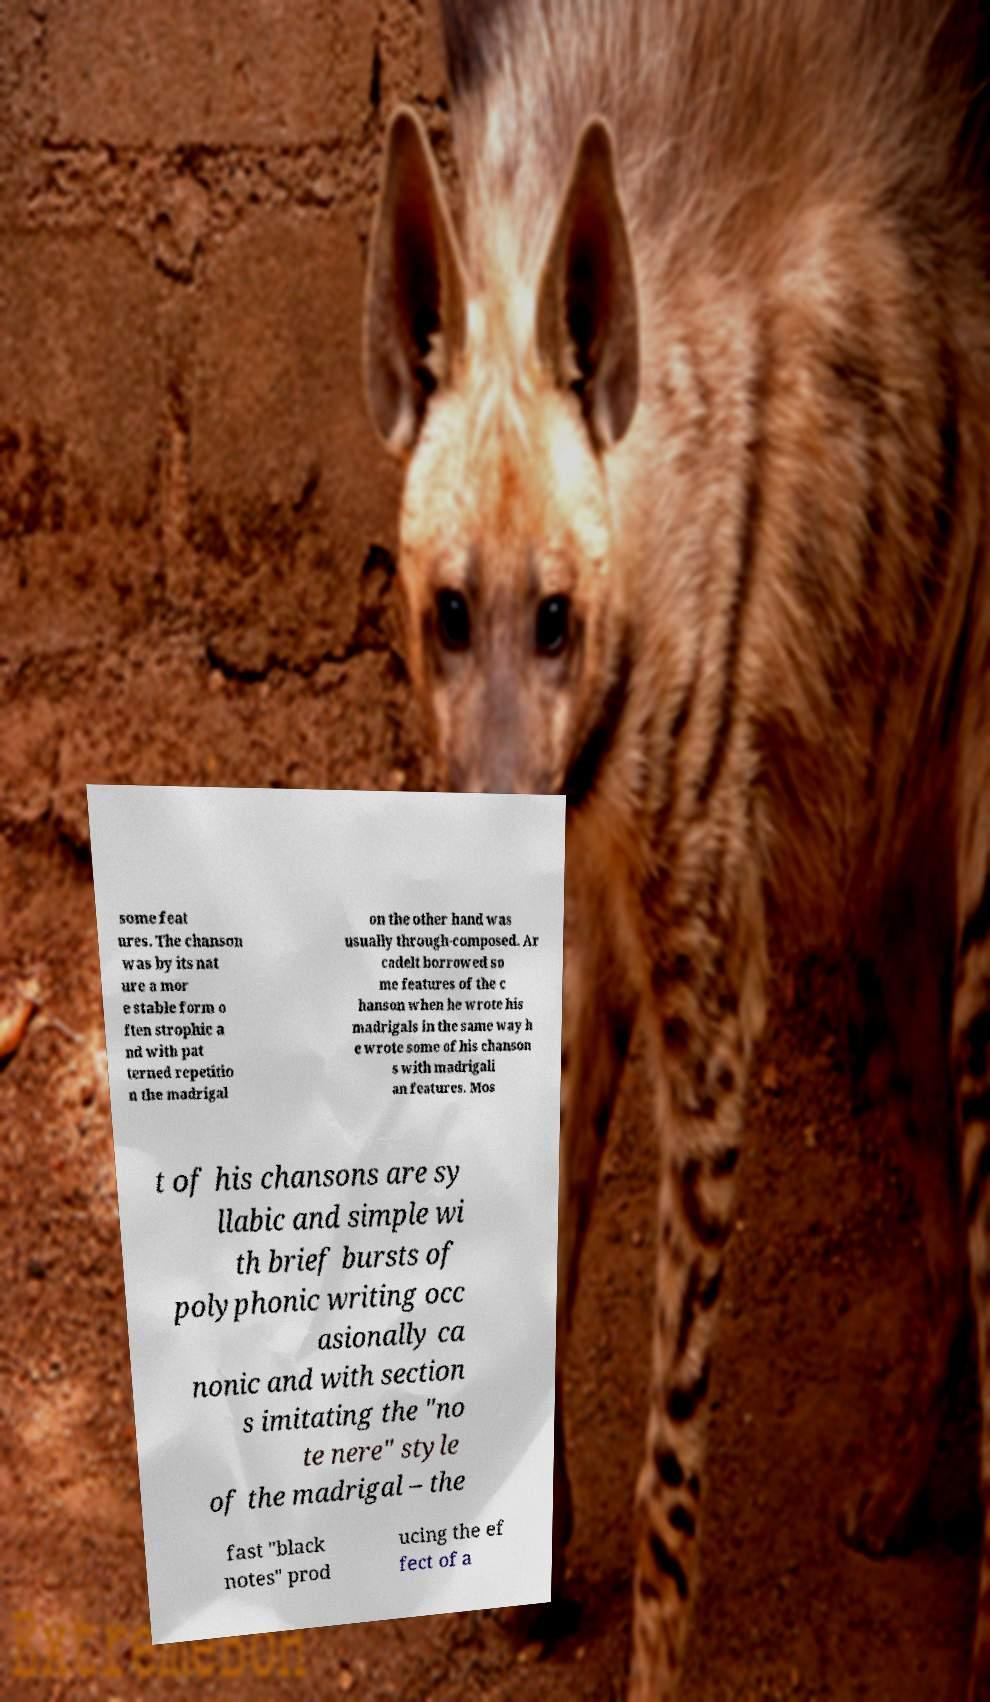What messages or text are displayed in this image? I need them in a readable, typed format. some feat ures. The chanson was by its nat ure a mor e stable form o ften strophic a nd with pat terned repetitio n the madrigal on the other hand was usually through-composed. Ar cadelt borrowed so me features of the c hanson when he wrote his madrigals in the same way h e wrote some of his chanson s with madrigali an features. Mos t of his chansons are sy llabic and simple wi th brief bursts of polyphonic writing occ asionally ca nonic and with section s imitating the "no te nere" style of the madrigal – the fast "black notes" prod ucing the ef fect of a 